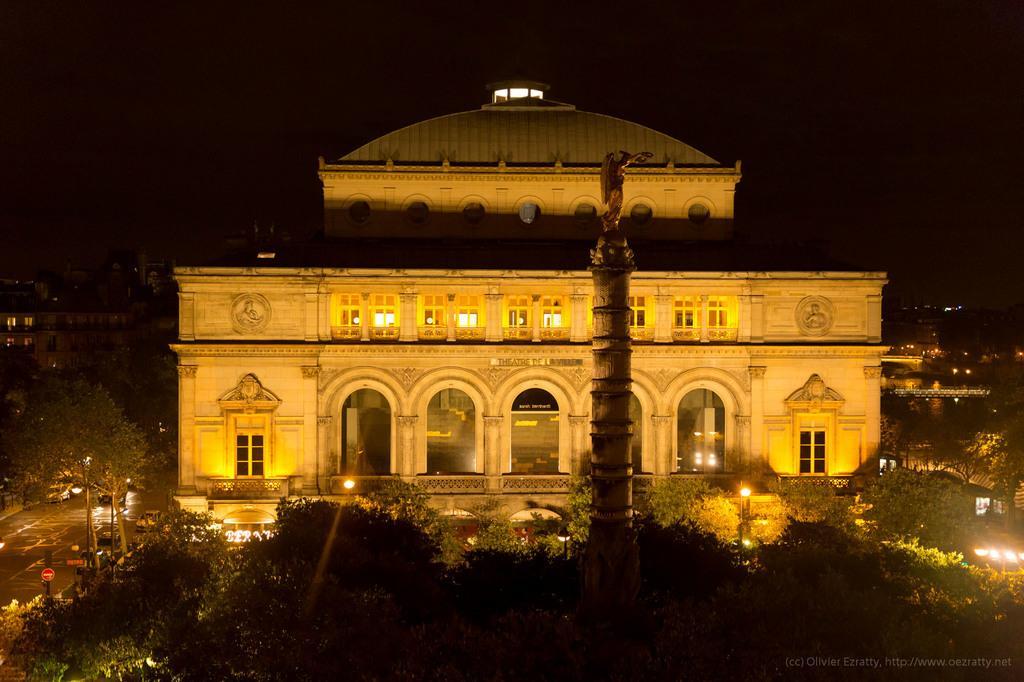Could you give a brief overview of what you see in this image? In this image we can see some buildings with windows and a tower. We can also see some vehicles on the road, a group of trees, some lights, poles, the signboards and the sky. 